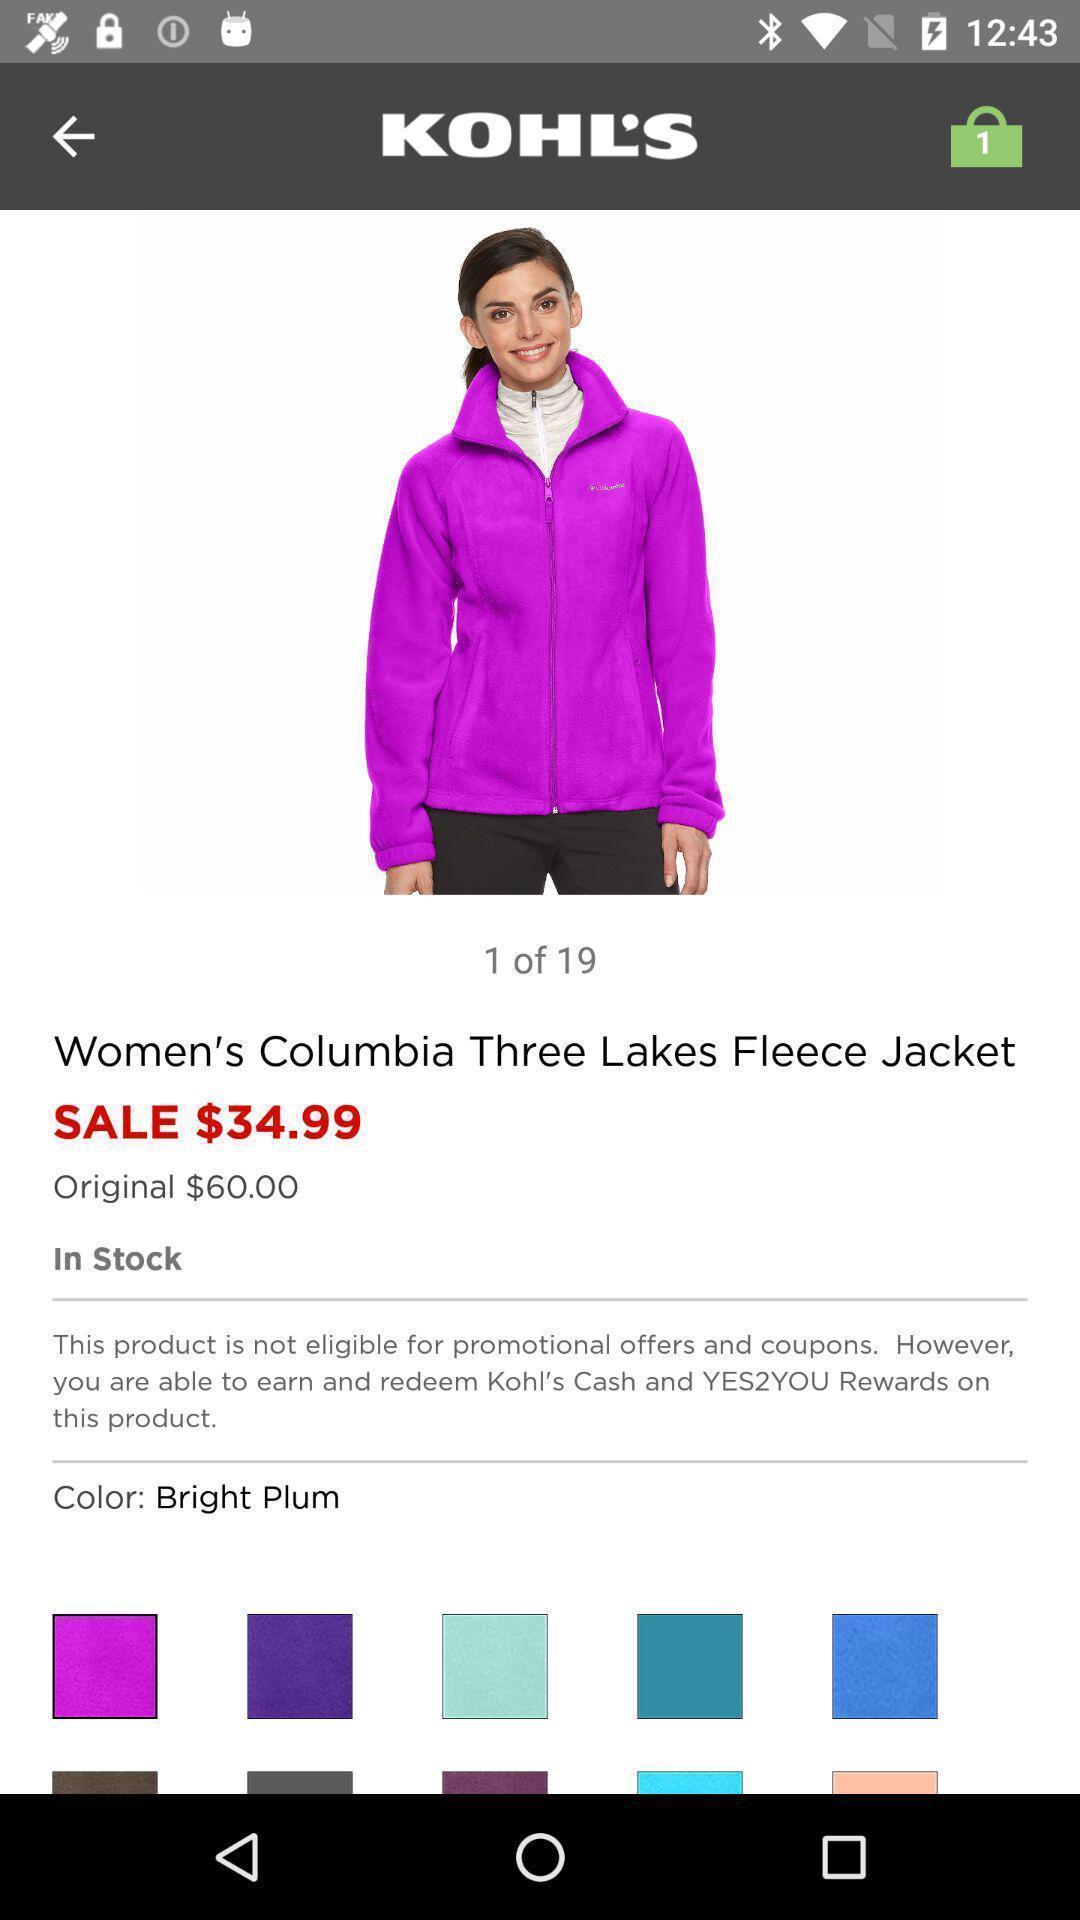Summarize the main components in this picture. Shopping app displayed an item with price and other info. 